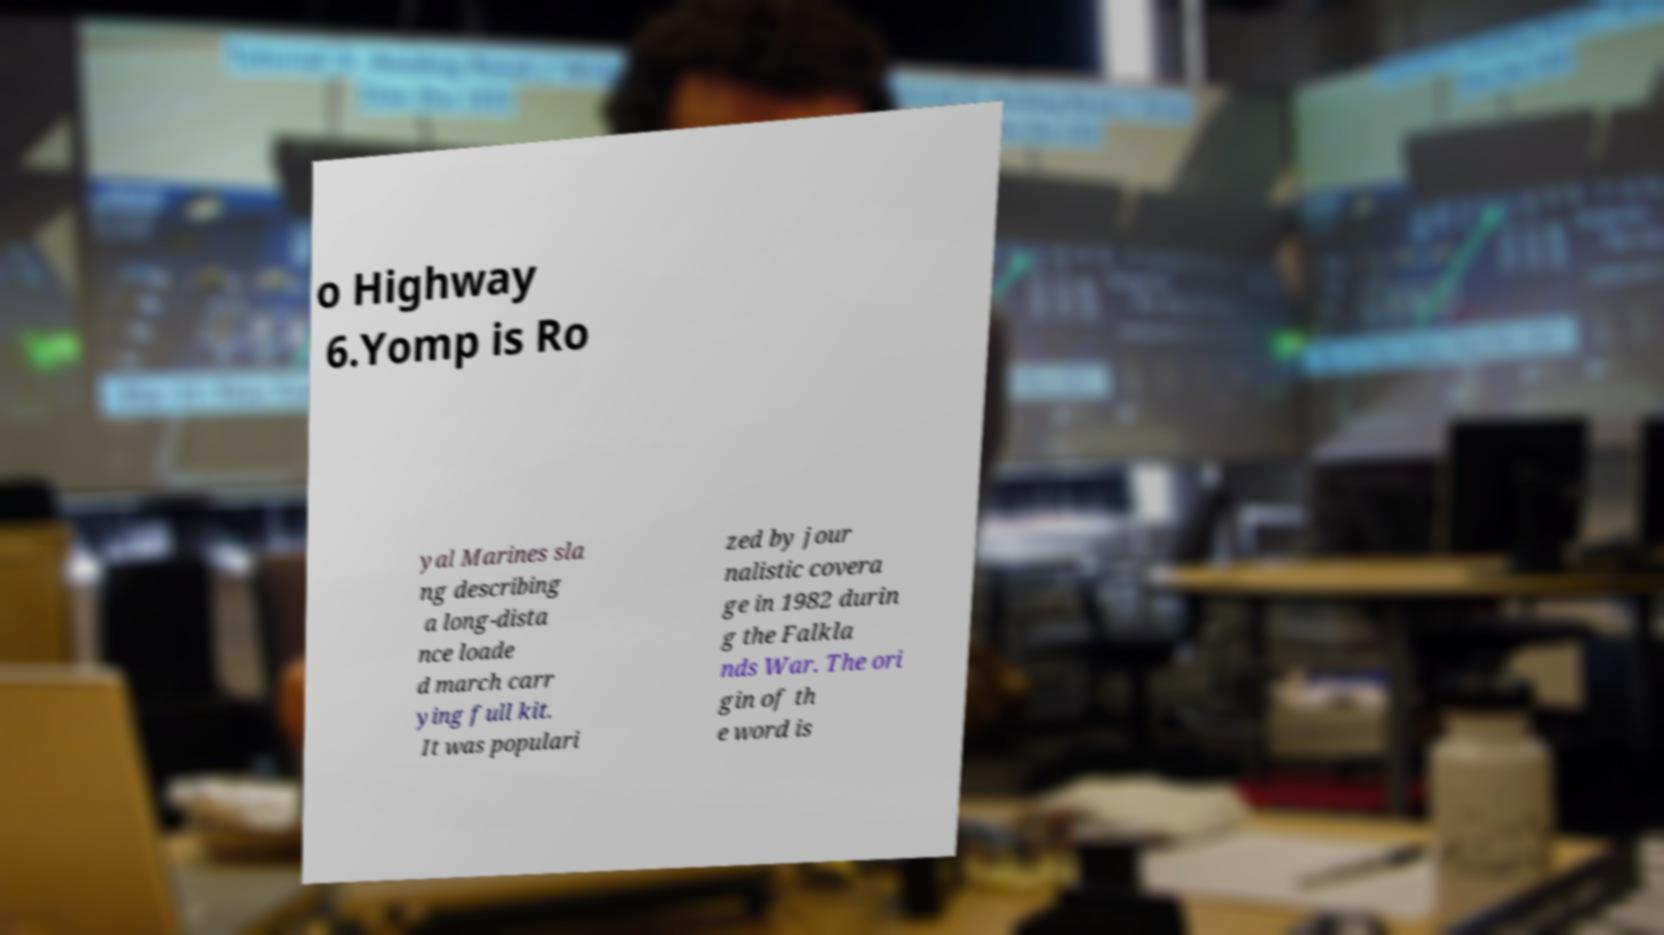Can you accurately transcribe the text from the provided image for me? o Highway 6.Yomp is Ro yal Marines sla ng describing a long-dista nce loade d march carr ying full kit. It was populari zed by jour nalistic covera ge in 1982 durin g the Falkla nds War. The ori gin of th e word is 